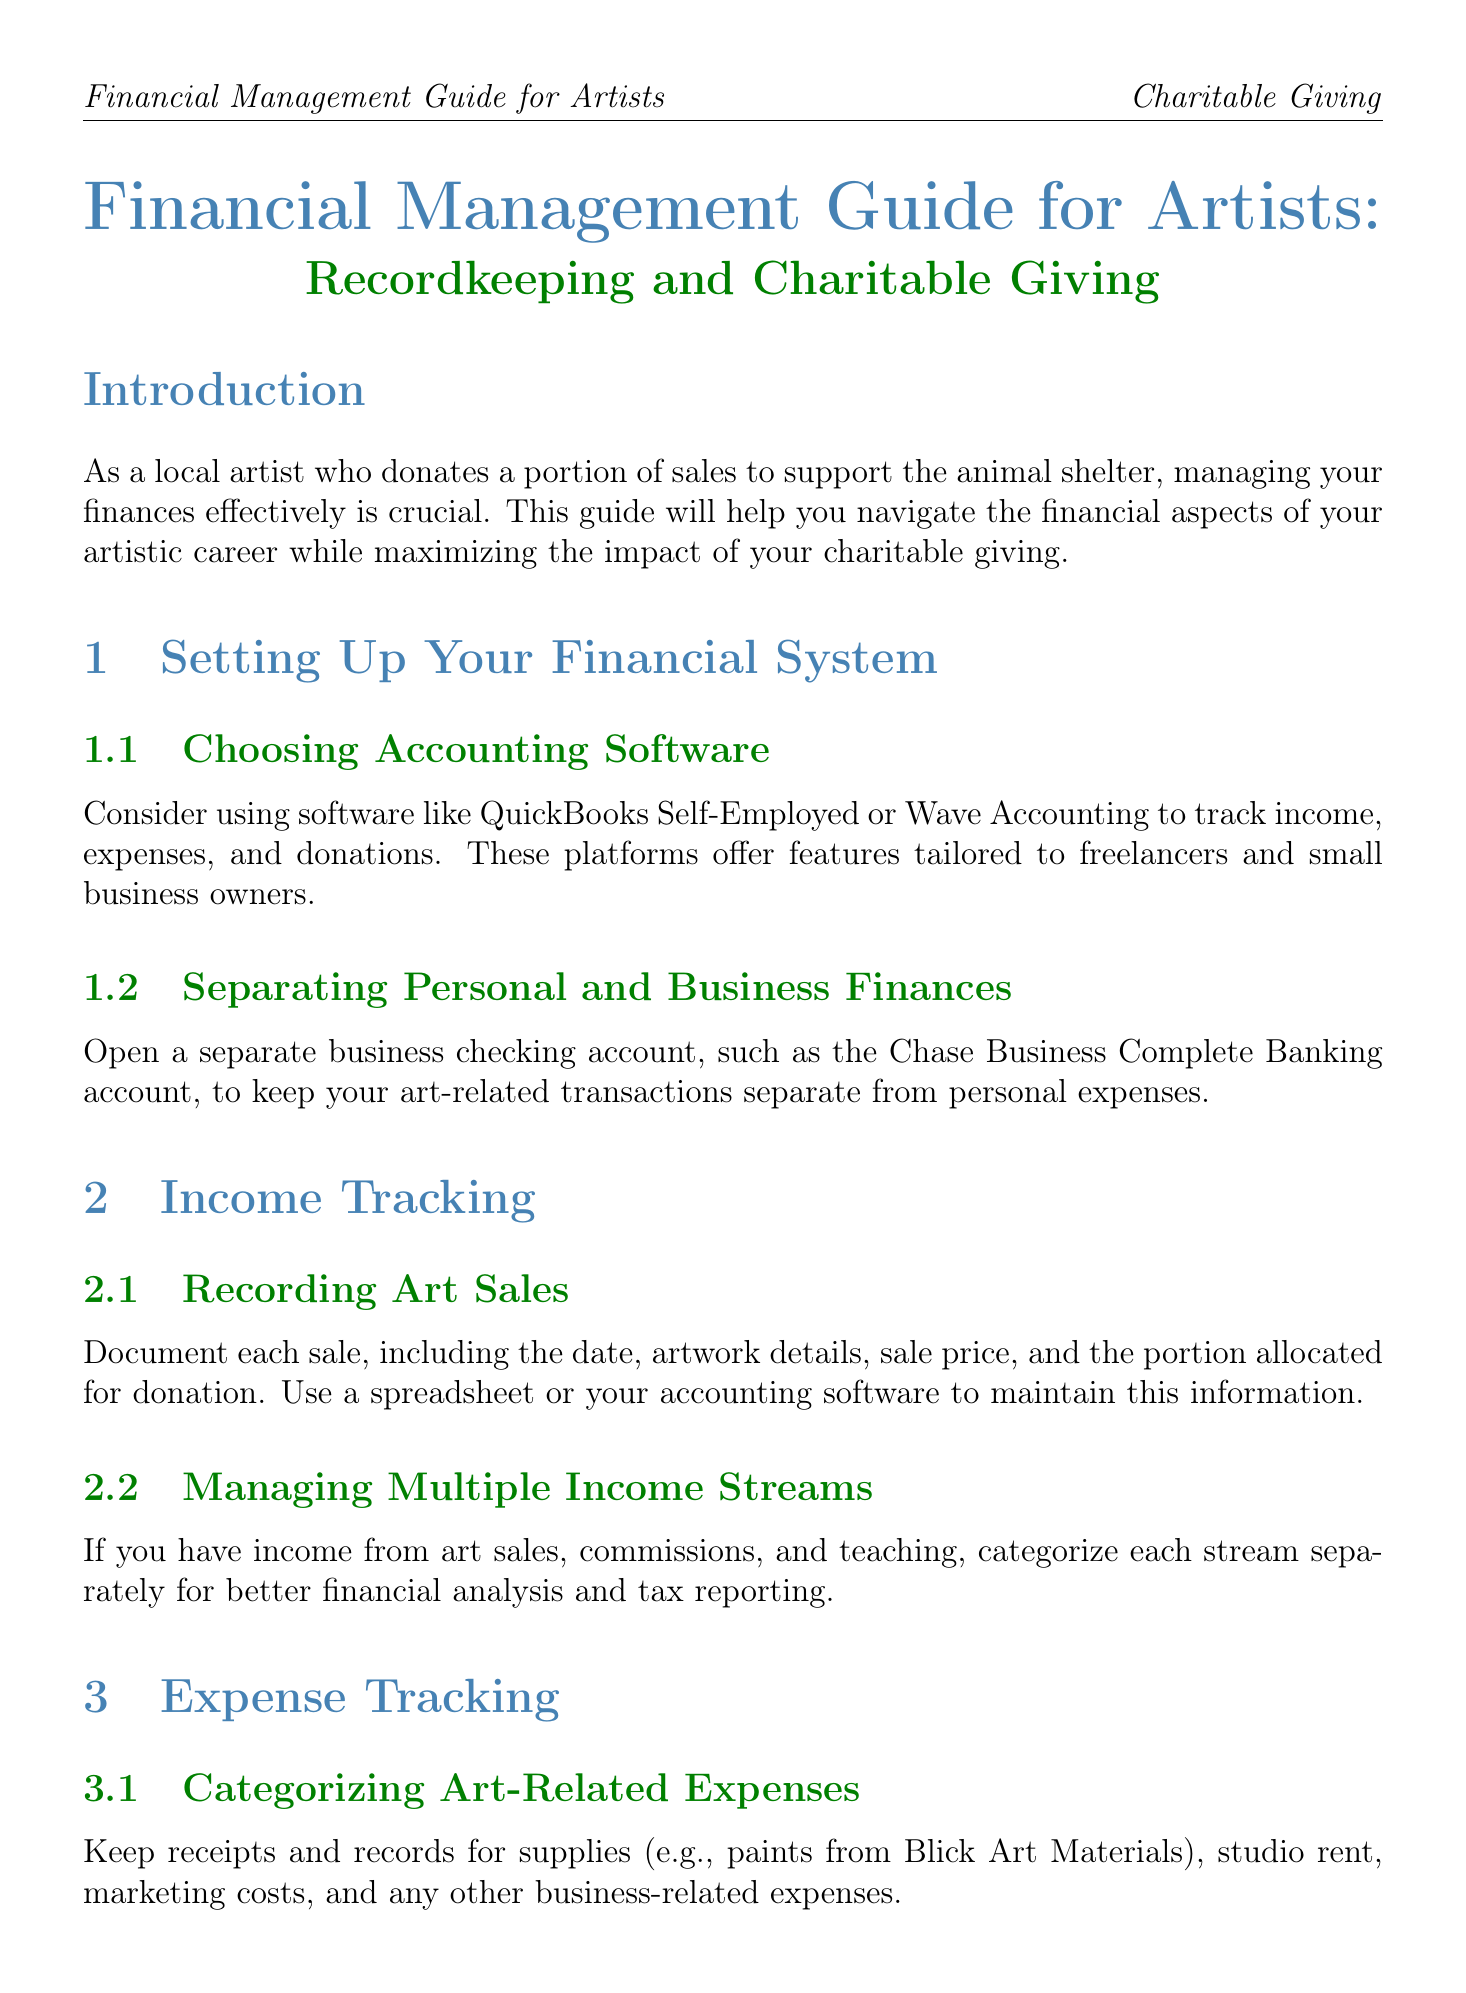What should you use to track income, expenses, and donations? The guide recommends using accounting software like QuickBooks Self-Employed or Wave Accounting for tracking these financial aspects.
Answer: QuickBooks Self-Employed or Wave Accounting What is the recommended percentage to set aside for self-employment taxes? It suggests setting aside approximately 15.3% of your net income for self-employment taxes.
Answer: 15.3% What types of expenses should you keep records for? The document states to keep records for art-related expenses such as supplies, studio rent, and marketing costs.
Answer: Art-related expenses What should you document when making donations to the animal shelter? Maintain a detailed log of all donations, including dates, amounts, and any acknowledgment letters received.
Answer: Detailed log What financial tool can help manage cash flow during fluctuating art sales? The guide mentions using YNAB (You Need A Budget) to manage cash flow effectively.
Answer: YNAB What is one way to increase charitable impact with the animal shelter? The document suggests discussing ways to increase impact, such as hosting art shows at the shelter.
Answer: Hosting art shows What type of account should you open to separate personal and business finances? It is recommended to open a separate business checking account to keep transactions separate.
Answer: Business checking account What professional appraisal is suggested for valuing donated artwork? The document advises obtaining a professional appraisal from a certified appraiser like the American Society of Appraisers for high-value pieces.
Answer: Certified appraiser 